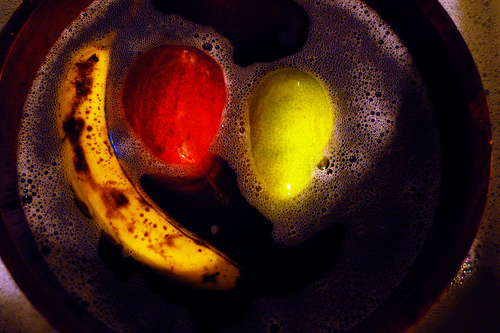<image>
Is the apple to the left of the banana? No. The apple is not to the left of the banana. From this viewpoint, they have a different horizontal relationship. 